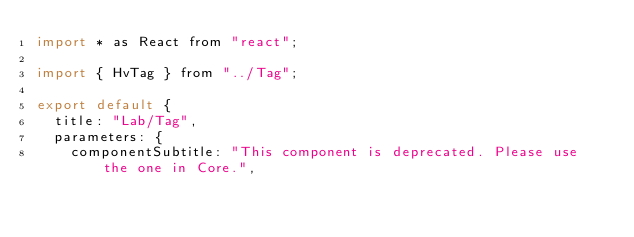Convert code to text. <code><loc_0><loc_0><loc_500><loc_500><_JavaScript_>import * as React from "react";

import { HvTag } from "../Tag";

export default {
  title: "Lab/Tag",
  parameters: {
    componentSubtitle: "This component is deprecated. Please use the one in Core.",</code> 